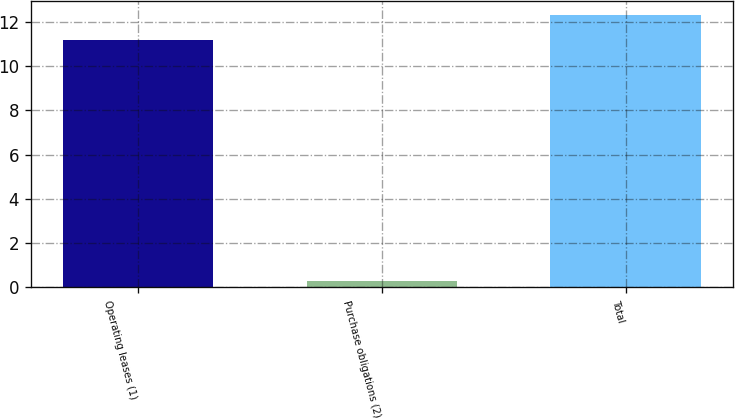Convert chart. <chart><loc_0><loc_0><loc_500><loc_500><bar_chart><fcel>Operating leases (1)<fcel>Purchase obligations (2)<fcel>Total<nl><fcel>11.2<fcel>0.3<fcel>12.32<nl></chart> 